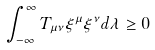<formula> <loc_0><loc_0><loc_500><loc_500>\int _ { - \infty } ^ { \infty } T _ { \mu \nu } \xi ^ { \mu } \xi ^ { \nu } d \lambda \geq 0</formula> 